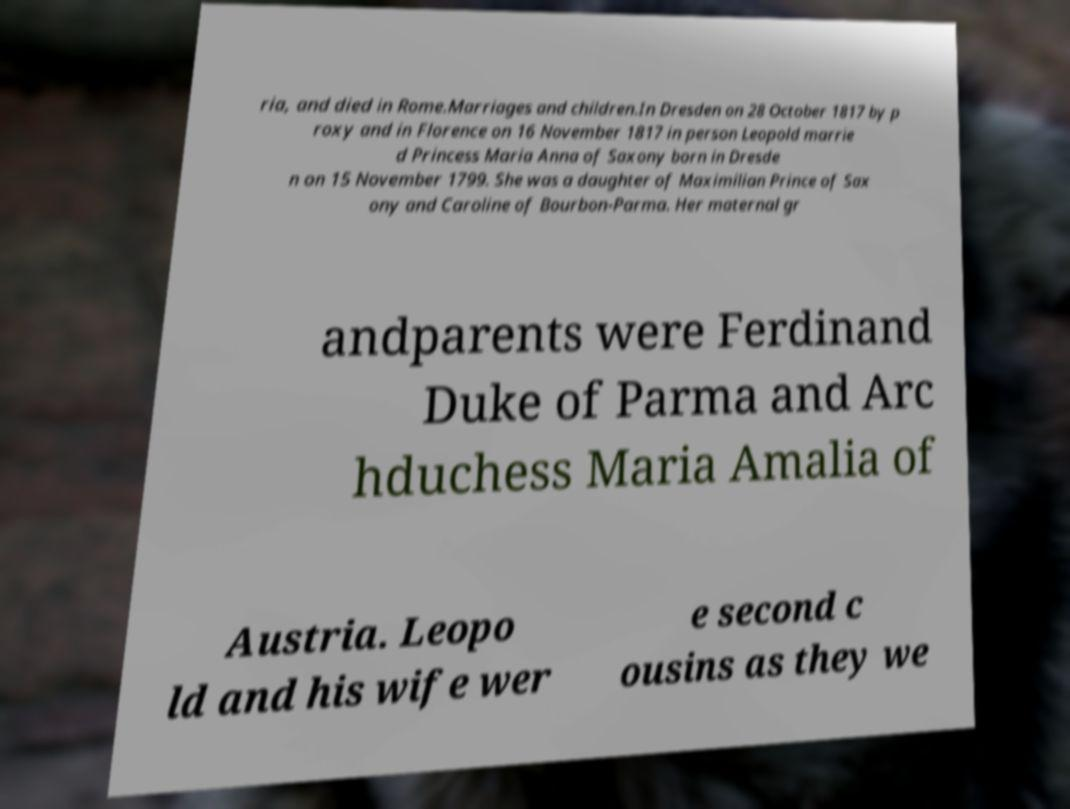What messages or text are displayed in this image? I need them in a readable, typed format. ria, and died in Rome.Marriages and children.In Dresden on 28 October 1817 by p roxy and in Florence on 16 November 1817 in person Leopold marrie d Princess Maria Anna of Saxony born in Dresde n on 15 November 1799. She was a daughter of Maximilian Prince of Sax ony and Caroline of Bourbon-Parma. Her maternal gr andparents were Ferdinand Duke of Parma and Arc hduchess Maria Amalia of Austria. Leopo ld and his wife wer e second c ousins as they we 